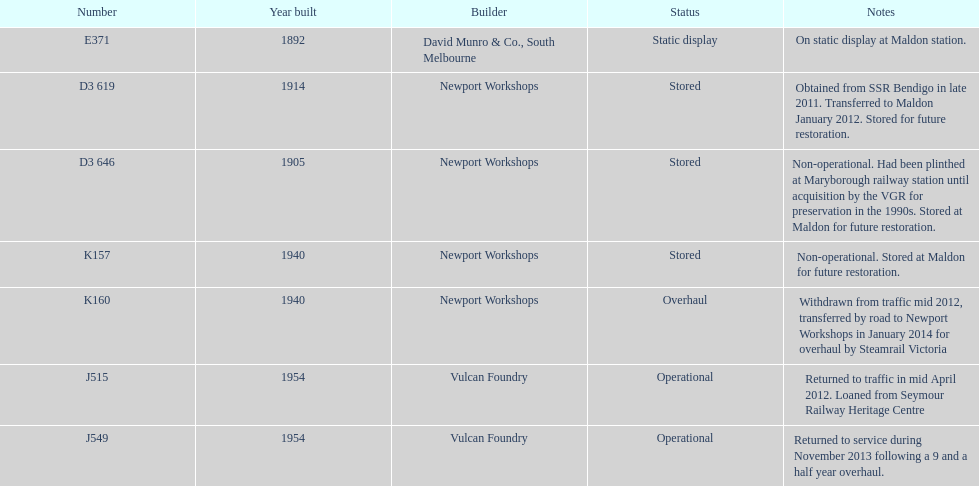How many of the locomotives were built before 1940? 3. Could you parse the entire table? {'header': ['Number', 'Year built', 'Builder', 'Status', 'Notes'], 'rows': [['E371', '1892', 'David Munro & Co., South Melbourne', 'Static display', 'On static display at Maldon station.'], ['D3 619', '1914', 'Newport Workshops', 'Stored', 'Obtained from SSR Bendigo in late 2011. Transferred to Maldon January 2012. Stored for future restoration.'], ['D3 646', '1905', 'Newport Workshops', 'Stored', 'Non-operational. Had been plinthed at Maryborough railway station until acquisition by the VGR for preservation in the 1990s. Stored at Maldon for future restoration.'], ['K157', '1940', 'Newport Workshops', 'Stored', 'Non-operational. Stored at Maldon for future restoration.'], ['K160', '1940', 'Newport Workshops', 'Overhaul', 'Withdrawn from traffic mid 2012, transferred by road to Newport Workshops in January 2014 for overhaul by Steamrail Victoria'], ['J515', '1954', 'Vulcan Foundry', 'Operational', 'Returned to traffic in mid April 2012. Loaned from Seymour Railway Heritage Centre'], ['J549', '1954', 'Vulcan Foundry', 'Operational', 'Returned to service during November 2013 following a 9 and a half year overhaul.']]} 